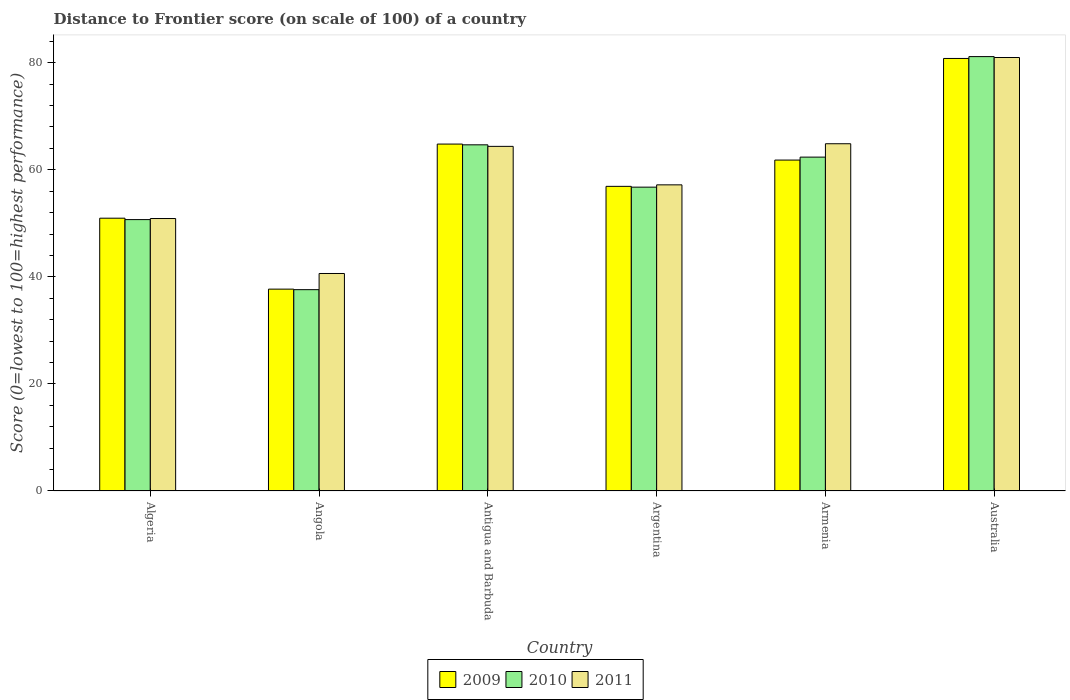How many different coloured bars are there?
Keep it short and to the point. 3. How many groups of bars are there?
Keep it short and to the point. 6. Are the number of bars on each tick of the X-axis equal?
Give a very brief answer. Yes. How many bars are there on the 2nd tick from the left?
Your answer should be very brief. 3. What is the label of the 2nd group of bars from the left?
Provide a short and direct response. Angola. What is the distance to frontier score of in 2010 in Australia?
Provide a succinct answer. 81.15. Across all countries, what is the maximum distance to frontier score of in 2009?
Keep it short and to the point. 80.8. Across all countries, what is the minimum distance to frontier score of in 2010?
Provide a succinct answer. 37.61. In which country was the distance to frontier score of in 2009 minimum?
Your response must be concise. Angola. What is the total distance to frontier score of in 2011 in the graph?
Make the answer very short. 358.95. What is the difference between the distance to frontier score of in 2011 in Antigua and Barbuda and that in Armenia?
Provide a short and direct response. -0.49. What is the difference between the distance to frontier score of in 2009 in Armenia and the distance to frontier score of in 2011 in Argentina?
Provide a short and direct response. 4.63. What is the average distance to frontier score of in 2009 per country?
Your response must be concise. 58.84. What is the difference between the distance to frontier score of of/in 2010 and distance to frontier score of of/in 2009 in Angola?
Keep it short and to the point. -0.1. What is the ratio of the distance to frontier score of in 2010 in Argentina to that in Australia?
Give a very brief answer. 0.7. Is the distance to frontier score of in 2009 in Angola less than that in Argentina?
Your answer should be very brief. Yes. Is the difference between the distance to frontier score of in 2010 in Angola and Armenia greater than the difference between the distance to frontier score of in 2009 in Angola and Armenia?
Make the answer very short. No. What is the difference between the highest and the second highest distance to frontier score of in 2011?
Ensure brevity in your answer.  16.6. What is the difference between the highest and the lowest distance to frontier score of in 2011?
Provide a succinct answer. 40.35. Is the sum of the distance to frontier score of in 2009 in Algeria and Angola greater than the maximum distance to frontier score of in 2010 across all countries?
Ensure brevity in your answer.  Yes. What does the 1st bar from the left in Australia represents?
Provide a short and direct response. 2009. How many bars are there?
Your response must be concise. 18. Are all the bars in the graph horizontal?
Offer a terse response. No. How many countries are there in the graph?
Make the answer very short. 6. Are the values on the major ticks of Y-axis written in scientific E-notation?
Your answer should be very brief. No. Does the graph contain any zero values?
Your answer should be very brief. No. Does the graph contain grids?
Make the answer very short. No. Where does the legend appear in the graph?
Offer a very short reply. Bottom center. How many legend labels are there?
Ensure brevity in your answer.  3. What is the title of the graph?
Offer a very short reply. Distance to Frontier score (on scale of 100) of a country. Does "1989" appear as one of the legend labels in the graph?
Your answer should be compact. No. What is the label or title of the Y-axis?
Your response must be concise. Score (0=lowest to 100=highest performance). What is the Score (0=lowest to 100=highest performance) of 2009 in Algeria?
Your answer should be very brief. 50.96. What is the Score (0=lowest to 100=highest performance) in 2010 in Algeria?
Keep it short and to the point. 50.7. What is the Score (0=lowest to 100=highest performance) in 2011 in Algeria?
Ensure brevity in your answer.  50.9. What is the Score (0=lowest to 100=highest performance) in 2009 in Angola?
Offer a terse response. 37.71. What is the Score (0=lowest to 100=highest performance) in 2010 in Angola?
Offer a terse response. 37.61. What is the Score (0=lowest to 100=highest performance) in 2011 in Angola?
Your response must be concise. 40.63. What is the Score (0=lowest to 100=highest performance) in 2009 in Antigua and Barbuda?
Offer a terse response. 64.81. What is the Score (0=lowest to 100=highest performance) in 2010 in Antigua and Barbuda?
Your answer should be compact. 64.67. What is the Score (0=lowest to 100=highest performance) in 2011 in Antigua and Barbuda?
Provide a short and direct response. 64.38. What is the Score (0=lowest to 100=highest performance) in 2009 in Argentina?
Your answer should be compact. 56.91. What is the Score (0=lowest to 100=highest performance) in 2010 in Argentina?
Provide a short and direct response. 56.76. What is the Score (0=lowest to 100=highest performance) in 2011 in Argentina?
Provide a succinct answer. 57.19. What is the Score (0=lowest to 100=highest performance) in 2009 in Armenia?
Provide a succinct answer. 61.82. What is the Score (0=lowest to 100=highest performance) of 2010 in Armenia?
Offer a very short reply. 62.37. What is the Score (0=lowest to 100=highest performance) of 2011 in Armenia?
Make the answer very short. 64.87. What is the Score (0=lowest to 100=highest performance) of 2009 in Australia?
Give a very brief answer. 80.8. What is the Score (0=lowest to 100=highest performance) in 2010 in Australia?
Offer a very short reply. 81.15. What is the Score (0=lowest to 100=highest performance) of 2011 in Australia?
Ensure brevity in your answer.  80.98. Across all countries, what is the maximum Score (0=lowest to 100=highest performance) of 2009?
Your response must be concise. 80.8. Across all countries, what is the maximum Score (0=lowest to 100=highest performance) in 2010?
Your response must be concise. 81.15. Across all countries, what is the maximum Score (0=lowest to 100=highest performance) in 2011?
Offer a terse response. 80.98. Across all countries, what is the minimum Score (0=lowest to 100=highest performance) in 2009?
Offer a very short reply. 37.71. Across all countries, what is the minimum Score (0=lowest to 100=highest performance) in 2010?
Provide a succinct answer. 37.61. Across all countries, what is the minimum Score (0=lowest to 100=highest performance) of 2011?
Offer a terse response. 40.63. What is the total Score (0=lowest to 100=highest performance) in 2009 in the graph?
Give a very brief answer. 353.01. What is the total Score (0=lowest to 100=highest performance) in 2010 in the graph?
Provide a short and direct response. 353.26. What is the total Score (0=lowest to 100=highest performance) in 2011 in the graph?
Your answer should be very brief. 358.95. What is the difference between the Score (0=lowest to 100=highest performance) of 2009 in Algeria and that in Angola?
Your response must be concise. 13.25. What is the difference between the Score (0=lowest to 100=highest performance) in 2010 in Algeria and that in Angola?
Offer a terse response. 13.09. What is the difference between the Score (0=lowest to 100=highest performance) in 2011 in Algeria and that in Angola?
Keep it short and to the point. 10.27. What is the difference between the Score (0=lowest to 100=highest performance) of 2009 in Algeria and that in Antigua and Barbuda?
Your answer should be compact. -13.85. What is the difference between the Score (0=lowest to 100=highest performance) of 2010 in Algeria and that in Antigua and Barbuda?
Provide a succinct answer. -13.97. What is the difference between the Score (0=lowest to 100=highest performance) of 2011 in Algeria and that in Antigua and Barbuda?
Provide a short and direct response. -13.48. What is the difference between the Score (0=lowest to 100=highest performance) of 2009 in Algeria and that in Argentina?
Offer a very short reply. -5.95. What is the difference between the Score (0=lowest to 100=highest performance) of 2010 in Algeria and that in Argentina?
Your response must be concise. -6.06. What is the difference between the Score (0=lowest to 100=highest performance) of 2011 in Algeria and that in Argentina?
Ensure brevity in your answer.  -6.29. What is the difference between the Score (0=lowest to 100=highest performance) in 2009 in Algeria and that in Armenia?
Ensure brevity in your answer.  -10.86. What is the difference between the Score (0=lowest to 100=highest performance) in 2010 in Algeria and that in Armenia?
Provide a succinct answer. -11.67. What is the difference between the Score (0=lowest to 100=highest performance) in 2011 in Algeria and that in Armenia?
Your response must be concise. -13.97. What is the difference between the Score (0=lowest to 100=highest performance) in 2009 in Algeria and that in Australia?
Your answer should be compact. -29.84. What is the difference between the Score (0=lowest to 100=highest performance) of 2010 in Algeria and that in Australia?
Offer a terse response. -30.45. What is the difference between the Score (0=lowest to 100=highest performance) of 2011 in Algeria and that in Australia?
Provide a succinct answer. -30.08. What is the difference between the Score (0=lowest to 100=highest performance) in 2009 in Angola and that in Antigua and Barbuda?
Your answer should be compact. -27.1. What is the difference between the Score (0=lowest to 100=highest performance) of 2010 in Angola and that in Antigua and Barbuda?
Your response must be concise. -27.06. What is the difference between the Score (0=lowest to 100=highest performance) of 2011 in Angola and that in Antigua and Barbuda?
Give a very brief answer. -23.75. What is the difference between the Score (0=lowest to 100=highest performance) in 2009 in Angola and that in Argentina?
Offer a very short reply. -19.2. What is the difference between the Score (0=lowest to 100=highest performance) of 2010 in Angola and that in Argentina?
Make the answer very short. -19.15. What is the difference between the Score (0=lowest to 100=highest performance) of 2011 in Angola and that in Argentina?
Make the answer very short. -16.56. What is the difference between the Score (0=lowest to 100=highest performance) of 2009 in Angola and that in Armenia?
Your answer should be very brief. -24.11. What is the difference between the Score (0=lowest to 100=highest performance) in 2010 in Angola and that in Armenia?
Offer a very short reply. -24.76. What is the difference between the Score (0=lowest to 100=highest performance) in 2011 in Angola and that in Armenia?
Provide a short and direct response. -24.24. What is the difference between the Score (0=lowest to 100=highest performance) of 2009 in Angola and that in Australia?
Provide a short and direct response. -43.09. What is the difference between the Score (0=lowest to 100=highest performance) of 2010 in Angola and that in Australia?
Offer a very short reply. -43.54. What is the difference between the Score (0=lowest to 100=highest performance) of 2011 in Angola and that in Australia?
Your answer should be compact. -40.35. What is the difference between the Score (0=lowest to 100=highest performance) in 2010 in Antigua and Barbuda and that in Argentina?
Offer a very short reply. 7.91. What is the difference between the Score (0=lowest to 100=highest performance) of 2011 in Antigua and Barbuda and that in Argentina?
Your response must be concise. 7.19. What is the difference between the Score (0=lowest to 100=highest performance) of 2009 in Antigua and Barbuda and that in Armenia?
Your answer should be compact. 2.99. What is the difference between the Score (0=lowest to 100=highest performance) in 2011 in Antigua and Barbuda and that in Armenia?
Give a very brief answer. -0.49. What is the difference between the Score (0=lowest to 100=highest performance) in 2009 in Antigua and Barbuda and that in Australia?
Make the answer very short. -15.99. What is the difference between the Score (0=lowest to 100=highest performance) of 2010 in Antigua and Barbuda and that in Australia?
Provide a succinct answer. -16.48. What is the difference between the Score (0=lowest to 100=highest performance) in 2011 in Antigua and Barbuda and that in Australia?
Offer a terse response. -16.6. What is the difference between the Score (0=lowest to 100=highest performance) of 2009 in Argentina and that in Armenia?
Give a very brief answer. -4.91. What is the difference between the Score (0=lowest to 100=highest performance) of 2010 in Argentina and that in Armenia?
Your answer should be compact. -5.61. What is the difference between the Score (0=lowest to 100=highest performance) of 2011 in Argentina and that in Armenia?
Keep it short and to the point. -7.68. What is the difference between the Score (0=lowest to 100=highest performance) of 2009 in Argentina and that in Australia?
Provide a short and direct response. -23.89. What is the difference between the Score (0=lowest to 100=highest performance) of 2010 in Argentina and that in Australia?
Your answer should be compact. -24.39. What is the difference between the Score (0=lowest to 100=highest performance) in 2011 in Argentina and that in Australia?
Your answer should be very brief. -23.79. What is the difference between the Score (0=lowest to 100=highest performance) in 2009 in Armenia and that in Australia?
Offer a very short reply. -18.98. What is the difference between the Score (0=lowest to 100=highest performance) in 2010 in Armenia and that in Australia?
Provide a short and direct response. -18.78. What is the difference between the Score (0=lowest to 100=highest performance) of 2011 in Armenia and that in Australia?
Keep it short and to the point. -16.11. What is the difference between the Score (0=lowest to 100=highest performance) of 2009 in Algeria and the Score (0=lowest to 100=highest performance) of 2010 in Angola?
Your answer should be very brief. 13.35. What is the difference between the Score (0=lowest to 100=highest performance) of 2009 in Algeria and the Score (0=lowest to 100=highest performance) of 2011 in Angola?
Your answer should be compact. 10.33. What is the difference between the Score (0=lowest to 100=highest performance) in 2010 in Algeria and the Score (0=lowest to 100=highest performance) in 2011 in Angola?
Your answer should be very brief. 10.07. What is the difference between the Score (0=lowest to 100=highest performance) in 2009 in Algeria and the Score (0=lowest to 100=highest performance) in 2010 in Antigua and Barbuda?
Give a very brief answer. -13.71. What is the difference between the Score (0=lowest to 100=highest performance) of 2009 in Algeria and the Score (0=lowest to 100=highest performance) of 2011 in Antigua and Barbuda?
Make the answer very short. -13.42. What is the difference between the Score (0=lowest to 100=highest performance) of 2010 in Algeria and the Score (0=lowest to 100=highest performance) of 2011 in Antigua and Barbuda?
Give a very brief answer. -13.68. What is the difference between the Score (0=lowest to 100=highest performance) of 2009 in Algeria and the Score (0=lowest to 100=highest performance) of 2010 in Argentina?
Provide a short and direct response. -5.8. What is the difference between the Score (0=lowest to 100=highest performance) in 2009 in Algeria and the Score (0=lowest to 100=highest performance) in 2011 in Argentina?
Offer a very short reply. -6.23. What is the difference between the Score (0=lowest to 100=highest performance) of 2010 in Algeria and the Score (0=lowest to 100=highest performance) of 2011 in Argentina?
Ensure brevity in your answer.  -6.49. What is the difference between the Score (0=lowest to 100=highest performance) of 2009 in Algeria and the Score (0=lowest to 100=highest performance) of 2010 in Armenia?
Your answer should be very brief. -11.41. What is the difference between the Score (0=lowest to 100=highest performance) in 2009 in Algeria and the Score (0=lowest to 100=highest performance) in 2011 in Armenia?
Provide a short and direct response. -13.91. What is the difference between the Score (0=lowest to 100=highest performance) in 2010 in Algeria and the Score (0=lowest to 100=highest performance) in 2011 in Armenia?
Provide a short and direct response. -14.17. What is the difference between the Score (0=lowest to 100=highest performance) in 2009 in Algeria and the Score (0=lowest to 100=highest performance) in 2010 in Australia?
Keep it short and to the point. -30.19. What is the difference between the Score (0=lowest to 100=highest performance) of 2009 in Algeria and the Score (0=lowest to 100=highest performance) of 2011 in Australia?
Make the answer very short. -30.02. What is the difference between the Score (0=lowest to 100=highest performance) in 2010 in Algeria and the Score (0=lowest to 100=highest performance) in 2011 in Australia?
Your answer should be very brief. -30.28. What is the difference between the Score (0=lowest to 100=highest performance) of 2009 in Angola and the Score (0=lowest to 100=highest performance) of 2010 in Antigua and Barbuda?
Offer a terse response. -26.96. What is the difference between the Score (0=lowest to 100=highest performance) in 2009 in Angola and the Score (0=lowest to 100=highest performance) in 2011 in Antigua and Barbuda?
Keep it short and to the point. -26.67. What is the difference between the Score (0=lowest to 100=highest performance) in 2010 in Angola and the Score (0=lowest to 100=highest performance) in 2011 in Antigua and Barbuda?
Offer a terse response. -26.77. What is the difference between the Score (0=lowest to 100=highest performance) of 2009 in Angola and the Score (0=lowest to 100=highest performance) of 2010 in Argentina?
Provide a succinct answer. -19.05. What is the difference between the Score (0=lowest to 100=highest performance) of 2009 in Angola and the Score (0=lowest to 100=highest performance) of 2011 in Argentina?
Offer a terse response. -19.48. What is the difference between the Score (0=lowest to 100=highest performance) in 2010 in Angola and the Score (0=lowest to 100=highest performance) in 2011 in Argentina?
Your answer should be compact. -19.58. What is the difference between the Score (0=lowest to 100=highest performance) in 2009 in Angola and the Score (0=lowest to 100=highest performance) in 2010 in Armenia?
Your answer should be compact. -24.66. What is the difference between the Score (0=lowest to 100=highest performance) of 2009 in Angola and the Score (0=lowest to 100=highest performance) of 2011 in Armenia?
Provide a succinct answer. -27.16. What is the difference between the Score (0=lowest to 100=highest performance) of 2010 in Angola and the Score (0=lowest to 100=highest performance) of 2011 in Armenia?
Your response must be concise. -27.26. What is the difference between the Score (0=lowest to 100=highest performance) in 2009 in Angola and the Score (0=lowest to 100=highest performance) in 2010 in Australia?
Make the answer very short. -43.44. What is the difference between the Score (0=lowest to 100=highest performance) in 2009 in Angola and the Score (0=lowest to 100=highest performance) in 2011 in Australia?
Your answer should be very brief. -43.27. What is the difference between the Score (0=lowest to 100=highest performance) in 2010 in Angola and the Score (0=lowest to 100=highest performance) in 2011 in Australia?
Keep it short and to the point. -43.37. What is the difference between the Score (0=lowest to 100=highest performance) in 2009 in Antigua and Barbuda and the Score (0=lowest to 100=highest performance) in 2010 in Argentina?
Your answer should be very brief. 8.05. What is the difference between the Score (0=lowest to 100=highest performance) in 2009 in Antigua and Barbuda and the Score (0=lowest to 100=highest performance) in 2011 in Argentina?
Offer a very short reply. 7.62. What is the difference between the Score (0=lowest to 100=highest performance) in 2010 in Antigua and Barbuda and the Score (0=lowest to 100=highest performance) in 2011 in Argentina?
Your answer should be compact. 7.48. What is the difference between the Score (0=lowest to 100=highest performance) of 2009 in Antigua and Barbuda and the Score (0=lowest to 100=highest performance) of 2010 in Armenia?
Provide a succinct answer. 2.44. What is the difference between the Score (0=lowest to 100=highest performance) in 2009 in Antigua and Barbuda and the Score (0=lowest to 100=highest performance) in 2011 in Armenia?
Keep it short and to the point. -0.06. What is the difference between the Score (0=lowest to 100=highest performance) in 2010 in Antigua and Barbuda and the Score (0=lowest to 100=highest performance) in 2011 in Armenia?
Make the answer very short. -0.2. What is the difference between the Score (0=lowest to 100=highest performance) in 2009 in Antigua and Barbuda and the Score (0=lowest to 100=highest performance) in 2010 in Australia?
Offer a terse response. -16.34. What is the difference between the Score (0=lowest to 100=highest performance) of 2009 in Antigua and Barbuda and the Score (0=lowest to 100=highest performance) of 2011 in Australia?
Offer a terse response. -16.17. What is the difference between the Score (0=lowest to 100=highest performance) of 2010 in Antigua and Barbuda and the Score (0=lowest to 100=highest performance) of 2011 in Australia?
Offer a very short reply. -16.31. What is the difference between the Score (0=lowest to 100=highest performance) in 2009 in Argentina and the Score (0=lowest to 100=highest performance) in 2010 in Armenia?
Offer a very short reply. -5.46. What is the difference between the Score (0=lowest to 100=highest performance) of 2009 in Argentina and the Score (0=lowest to 100=highest performance) of 2011 in Armenia?
Give a very brief answer. -7.96. What is the difference between the Score (0=lowest to 100=highest performance) of 2010 in Argentina and the Score (0=lowest to 100=highest performance) of 2011 in Armenia?
Your answer should be compact. -8.11. What is the difference between the Score (0=lowest to 100=highest performance) of 2009 in Argentina and the Score (0=lowest to 100=highest performance) of 2010 in Australia?
Give a very brief answer. -24.24. What is the difference between the Score (0=lowest to 100=highest performance) of 2009 in Argentina and the Score (0=lowest to 100=highest performance) of 2011 in Australia?
Offer a terse response. -24.07. What is the difference between the Score (0=lowest to 100=highest performance) of 2010 in Argentina and the Score (0=lowest to 100=highest performance) of 2011 in Australia?
Your answer should be very brief. -24.22. What is the difference between the Score (0=lowest to 100=highest performance) in 2009 in Armenia and the Score (0=lowest to 100=highest performance) in 2010 in Australia?
Your answer should be compact. -19.33. What is the difference between the Score (0=lowest to 100=highest performance) in 2009 in Armenia and the Score (0=lowest to 100=highest performance) in 2011 in Australia?
Ensure brevity in your answer.  -19.16. What is the difference between the Score (0=lowest to 100=highest performance) of 2010 in Armenia and the Score (0=lowest to 100=highest performance) of 2011 in Australia?
Your answer should be very brief. -18.61. What is the average Score (0=lowest to 100=highest performance) in 2009 per country?
Offer a terse response. 58.84. What is the average Score (0=lowest to 100=highest performance) in 2010 per country?
Provide a succinct answer. 58.88. What is the average Score (0=lowest to 100=highest performance) of 2011 per country?
Your answer should be very brief. 59.83. What is the difference between the Score (0=lowest to 100=highest performance) of 2009 and Score (0=lowest to 100=highest performance) of 2010 in Algeria?
Give a very brief answer. 0.26. What is the difference between the Score (0=lowest to 100=highest performance) in 2009 and Score (0=lowest to 100=highest performance) in 2011 in Algeria?
Give a very brief answer. 0.06. What is the difference between the Score (0=lowest to 100=highest performance) in 2010 and Score (0=lowest to 100=highest performance) in 2011 in Algeria?
Make the answer very short. -0.2. What is the difference between the Score (0=lowest to 100=highest performance) in 2009 and Score (0=lowest to 100=highest performance) in 2010 in Angola?
Ensure brevity in your answer.  0.1. What is the difference between the Score (0=lowest to 100=highest performance) of 2009 and Score (0=lowest to 100=highest performance) of 2011 in Angola?
Offer a very short reply. -2.92. What is the difference between the Score (0=lowest to 100=highest performance) of 2010 and Score (0=lowest to 100=highest performance) of 2011 in Angola?
Your answer should be very brief. -3.02. What is the difference between the Score (0=lowest to 100=highest performance) of 2009 and Score (0=lowest to 100=highest performance) of 2010 in Antigua and Barbuda?
Make the answer very short. 0.14. What is the difference between the Score (0=lowest to 100=highest performance) in 2009 and Score (0=lowest to 100=highest performance) in 2011 in Antigua and Barbuda?
Make the answer very short. 0.43. What is the difference between the Score (0=lowest to 100=highest performance) in 2010 and Score (0=lowest to 100=highest performance) in 2011 in Antigua and Barbuda?
Your response must be concise. 0.29. What is the difference between the Score (0=lowest to 100=highest performance) of 2009 and Score (0=lowest to 100=highest performance) of 2011 in Argentina?
Offer a very short reply. -0.28. What is the difference between the Score (0=lowest to 100=highest performance) of 2010 and Score (0=lowest to 100=highest performance) of 2011 in Argentina?
Keep it short and to the point. -0.43. What is the difference between the Score (0=lowest to 100=highest performance) in 2009 and Score (0=lowest to 100=highest performance) in 2010 in Armenia?
Your response must be concise. -0.55. What is the difference between the Score (0=lowest to 100=highest performance) in 2009 and Score (0=lowest to 100=highest performance) in 2011 in Armenia?
Your answer should be very brief. -3.05. What is the difference between the Score (0=lowest to 100=highest performance) of 2010 and Score (0=lowest to 100=highest performance) of 2011 in Armenia?
Provide a short and direct response. -2.5. What is the difference between the Score (0=lowest to 100=highest performance) of 2009 and Score (0=lowest to 100=highest performance) of 2010 in Australia?
Keep it short and to the point. -0.35. What is the difference between the Score (0=lowest to 100=highest performance) of 2009 and Score (0=lowest to 100=highest performance) of 2011 in Australia?
Provide a short and direct response. -0.18. What is the difference between the Score (0=lowest to 100=highest performance) of 2010 and Score (0=lowest to 100=highest performance) of 2011 in Australia?
Provide a short and direct response. 0.17. What is the ratio of the Score (0=lowest to 100=highest performance) in 2009 in Algeria to that in Angola?
Your answer should be very brief. 1.35. What is the ratio of the Score (0=lowest to 100=highest performance) in 2010 in Algeria to that in Angola?
Provide a short and direct response. 1.35. What is the ratio of the Score (0=lowest to 100=highest performance) of 2011 in Algeria to that in Angola?
Make the answer very short. 1.25. What is the ratio of the Score (0=lowest to 100=highest performance) in 2009 in Algeria to that in Antigua and Barbuda?
Your answer should be compact. 0.79. What is the ratio of the Score (0=lowest to 100=highest performance) in 2010 in Algeria to that in Antigua and Barbuda?
Your answer should be very brief. 0.78. What is the ratio of the Score (0=lowest to 100=highest performance) in 2011 in Algeria to that in Antigua and Barbuda?
Ensure brevity in your answer.  0.79. What is the ratio of the Score (0=lowest to 100=highest performance) of 2009 in Algeria to that in Argentina?
Your response must be concise. 0.9. What is the ratio of the Score (0=lowest to 100=highest performance) of 2010 in Algeria to that in Argentina?
Your response must be concise. 0.89. What is the ratio of the Score (0=lowest to 100=highest performance) in 2011 in Algeria to that in Argentina?
Keep it short and to the point. 0.89. What is the ratio of the Score (0=lowest to 100=highest performance) of 2009 in Algeria to that in Armenia?
Offer a terse response. 0.82. What is the ratio of the Score (0=lowest to 100=highest performance) in 2010 in Algeria to that in Armenia?
Provide a succinct answer. 0.81. What is the ratio of the Score (0=lowest to 100=highest performance) in 2011 in Algeria to that in Armenia?
Offer a very short reply. 0.78. What is the ratio of the Score (0=lowest to 100=highest performance) of 2009 in Algeria to that in Australia?
Make the answer very short. 0.63. What is the ratio of the Score (0=lowest to 100=highest performance) of 2010 in Algeria to that in Australia?
Offer a very short reply. 0.62. What is the ratio of the Score (0=lowest to 100=highest performance) of 2011 in Algeria to that in Australia?
Give a very brief answer. 0.63. What is the ratio of the Score (0=lowest to 100=highest performance) of 2009 in Angola to that in Antigua and Barbuda?
Keep it short and to the point. 0.58. What is the ratio of the Score (0=lowest to 100=highest performance) of 2010 in Angola to that in Antigua and Barbuda?
Your answer should be compact. 0.58. What is the ratio of the Score (0=lowest to 100=highest performance) of 2011 in Angola to that in Antigua and Barbuda?
Your answer should be compact. 0.63. What is the ratio of the Score (0=lowest to 100=highest performance) of 2009 in Angola to that in Argentina?
Offer a very short reply. 0.66. What is the ratio of the Score (0=lowest to 100=highest performance) in 2010 in Angola to that in Argentina?
Your answer should be very brief. 0.66. What is the ratio of the Score (0=lowest to 100=highest performance) of 2011 in Angola to that in Argentina?
Keep it short and to the point. 0.71. What is the ratio of the Score (0=lowest to 100=highest performance) in 2009 in Angola to that in Armenia?
Your response must be concise. 0.61. What is the ratio of the Score (0=lowest to 100=highest performance) in 2010 in Angola to that in Armenia?
Make the answer very short. 0.6. What is the ratio of the Score (0=lowest to 100=highest performance) of 2011 in Angola to that in Armenia?
Offer a terse response. 0.63. What is the ratio of the Score (0=lowest to 100=highest performance) in 2009 in Angola to that in Australia?
Provide a short and direct response. 0.47. What is the ratio of the Score (0=lowest to 100=highest performance) in 2010 in Angola to that in Australia?
Offer a very short reply. 0.46. What is the ratio of the Score (0=lowest to 100=highest performance) in 2011 in Angola to that in Australia?
Make the answer very short. 0.5. What is the ratio of the Score (0=lowest to 100=highest performance) in 2009 in Antigua and Barbuda to that in Argentina?
Ensure brevity in your answer.  1.14. What is the ratio of the Score (0=lowest to 100=highest performance) in 2010 in Antigua and Barbuda to that in Argentina?
Ensure brevity in your answer.  1.14. What is the ratio of the Score (0=lowest to 100=highest performance) in 2011 in Antigua and Barbuda to that in Argentina?
Offer a very short reply. 1.13. What is the ratio of the Score (0=lowest to 100=highest performance) of 2009 in Antigua and Barbuda to that in Armenia?
Give a very brief answer. 1.05. What is the ratio of the Score (0=lowest to 100=highest performance) of 2010 in Antigua and Barbuda to that in Armenia?
Your response must be concise. 1.04. What is the ratio of the Score (0=lowest to 100=highest performance) of 2011 in Antigua and Barbuda to that in Armenia?
Your answer should be compact. 0.99. What is the ratio of the Score (0=lowest to 100=highest performance) of 2009 in Antigua and Barbuda to that in Australia?
Your response must be concise. 0.8. What is the ratio of the Score (0=lowest to 100=highest performance) in 2010 in Antigua and Barbuda to that in Australia?
Your response must be concise. 0.8. What is the ratio of the Score (0=lowest to 100=highest performance) of 2011 in Antigua and Barbuda to that in Australia?
Give a very brief answer. 0.8. What is the ratio of the Score (0=lowest to 100=highest performance) of 2009 in Argentina to that in Armenia?
Your answer should be compact. 0.92. What is the ratio of the Score (0=lowest to 100=highest performance) in 2010 in Argentina to that in Armenia?
Keep it short and to the point. 0.91. What is the ratio of the Score (0=lowest to 100=highest performance) in 2011 in Argentina to that in Armenia?
Offer a very short reply. 0.88. What is the ratio of the Score (0=lowest to 100=highest performance) of 2009 in Argentina to that in Australia?
Offer a terse response. 0.7. What is the ratio of the Score (0=lowest to 100=highest performance) of 2010 in Argentina to that in Australia?
Offer a terse response. 0.7. What is the ratio of the Score (0=lowest to 100=highest performance) in 2011 in Argentina to that in Australia?
Offer a terse response. 0.71. What is the ratio of the Score (0=lowest to 100=highest performance) in 2009 in Armenia to that in Australia?
Your answer should be very brief. 0.77. What is the ratio of the Score (0=lowest to 100=highest performance) in 2010 in Armenia to that in Australia?
Give a very brief answer. 0.77. What is the ratio of the Score (0=lowest to 100=highest performance) of 2011 in Armenia to that in Australia?
Provide a short and direct response. 0.8. What is the difference between the highest and the second highest Score (0=lowest to 100=highest performance) of 2009?
Provide a succinct answer. 15.99. What is the difference between the highest and the second highest Score (0=lowest to 100=highest performance) in 2010?
Keep it short and to the point. 16.48. What is the difference between the highest and the second highest Score (0=lowest to 100=highest performance) in 2011?
Your answer should be very brief. 16.11. What is the difference between the highest and the lowest Score (0=lowest to 100=highest performance) in 2009?
Provide a succinct answer. 43.09. What is the difference between the highest and the lowest Score (0=lowest to 100=highest performance) in 2010?
Your answer should be very brief. 43.54. What is the difference between the highest and the lowest Score (0=lowest to 100=highest performance) in 2011?
Offer a very short reply. 40.35. 